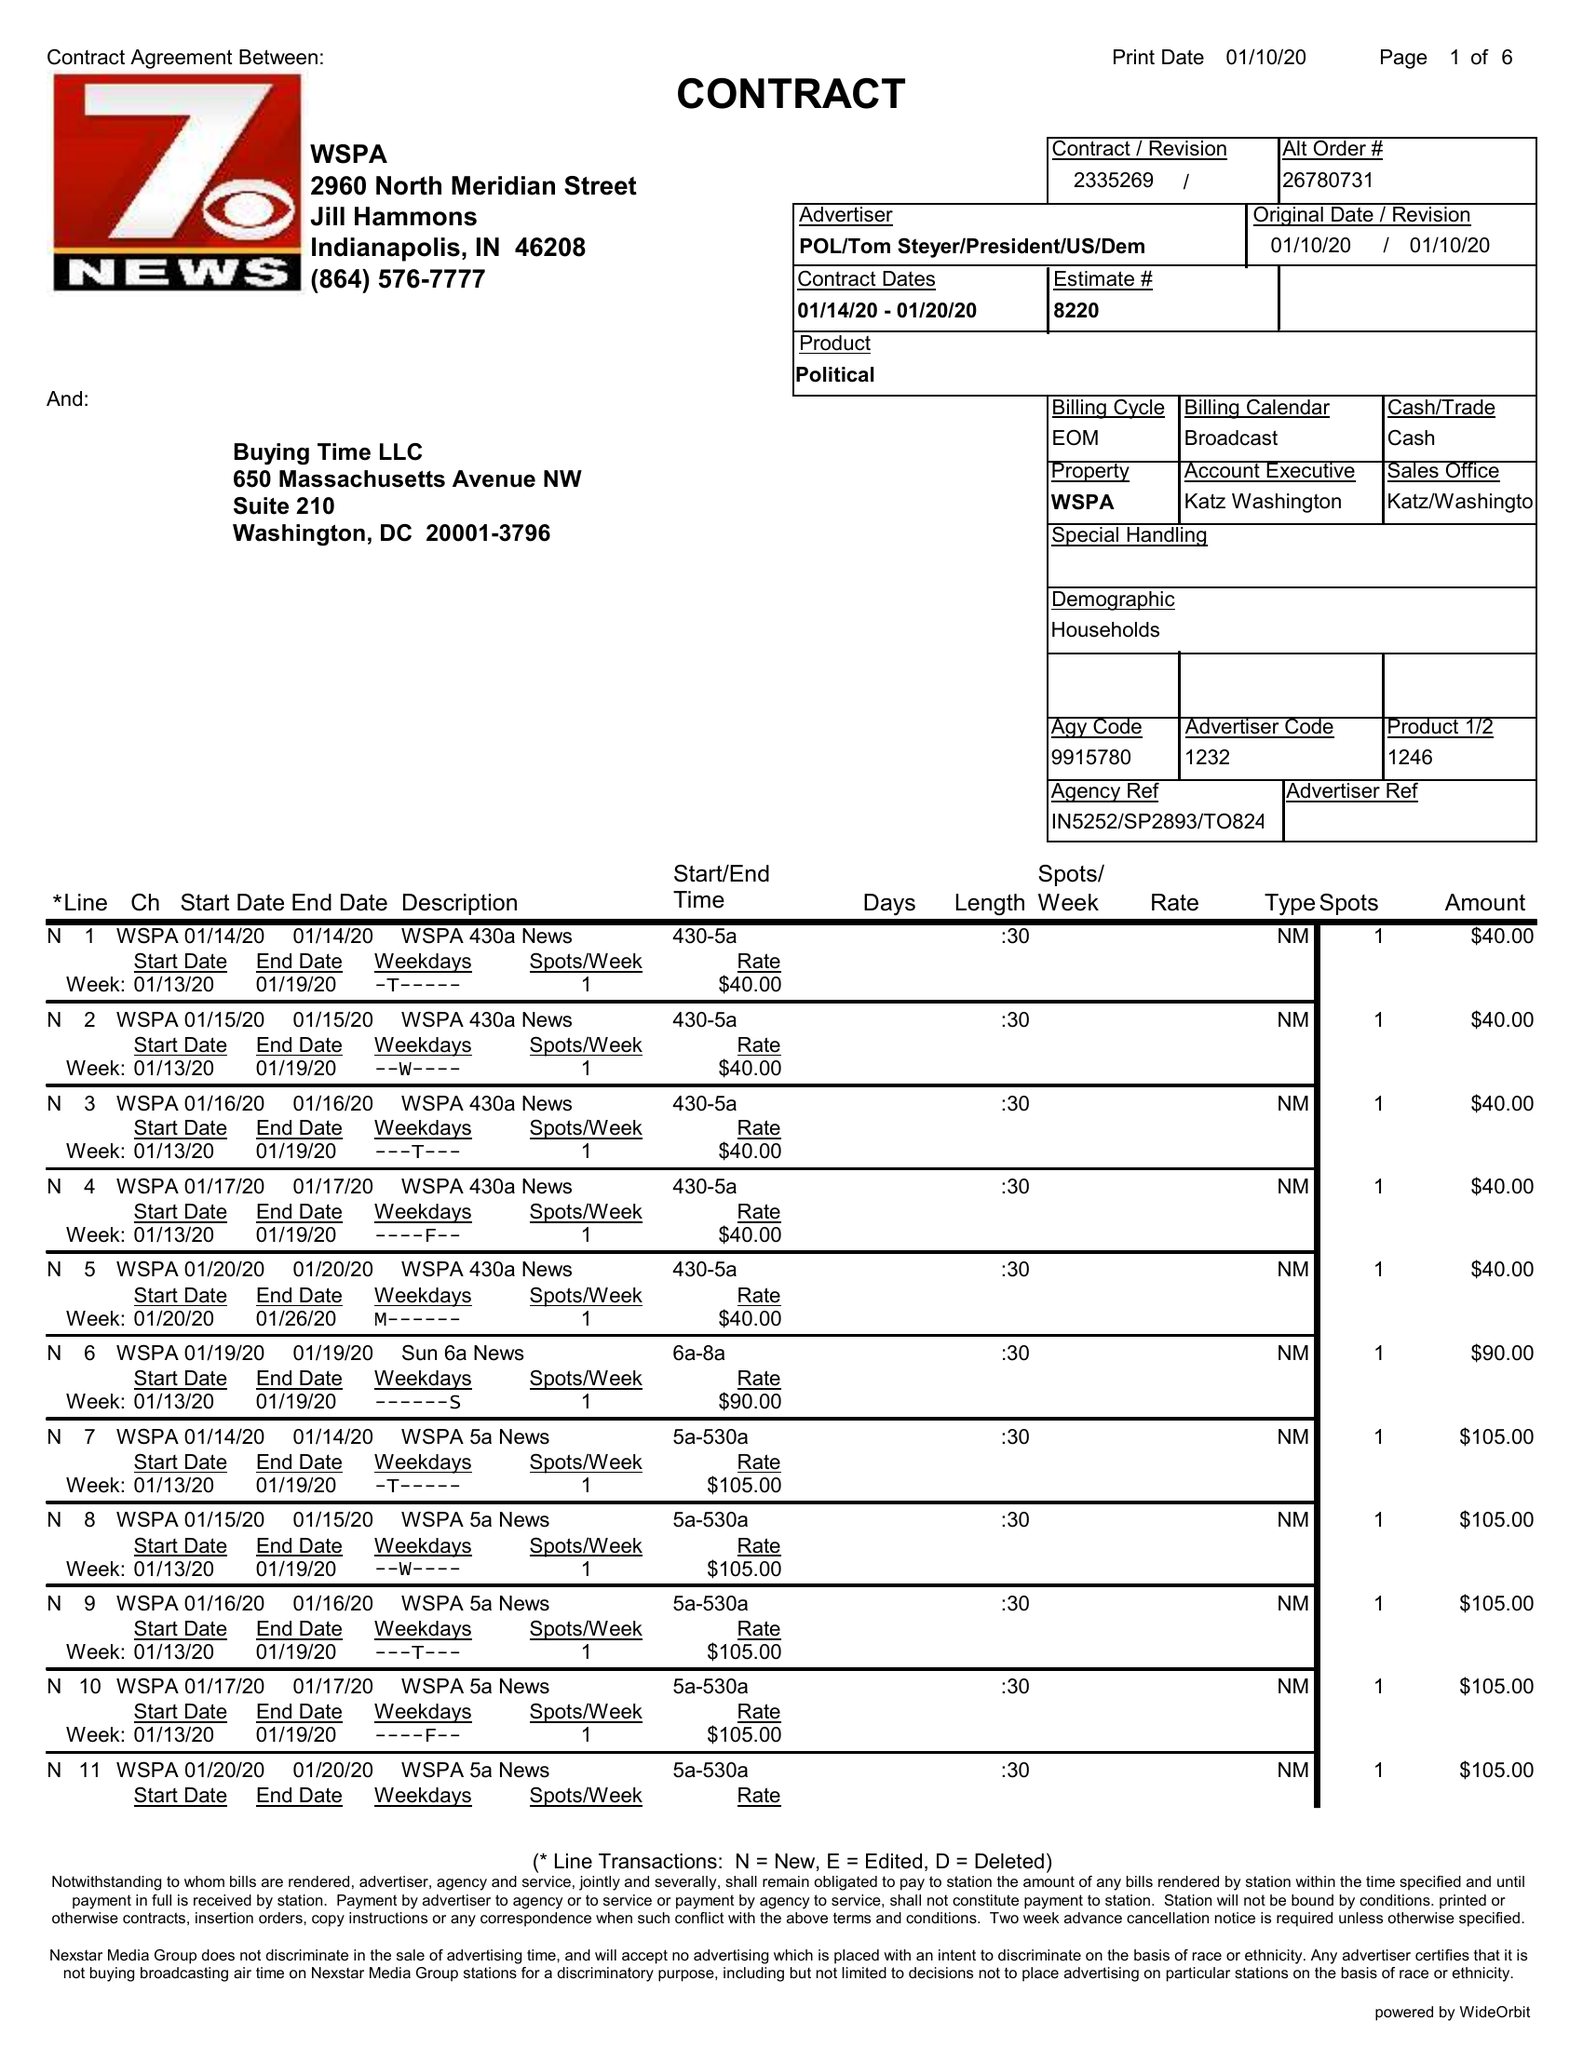What is the value for the advertiser?
Answer the question using a single word or phrase. POL/TOMSTEYER/PRESIDENT/US/DEM 